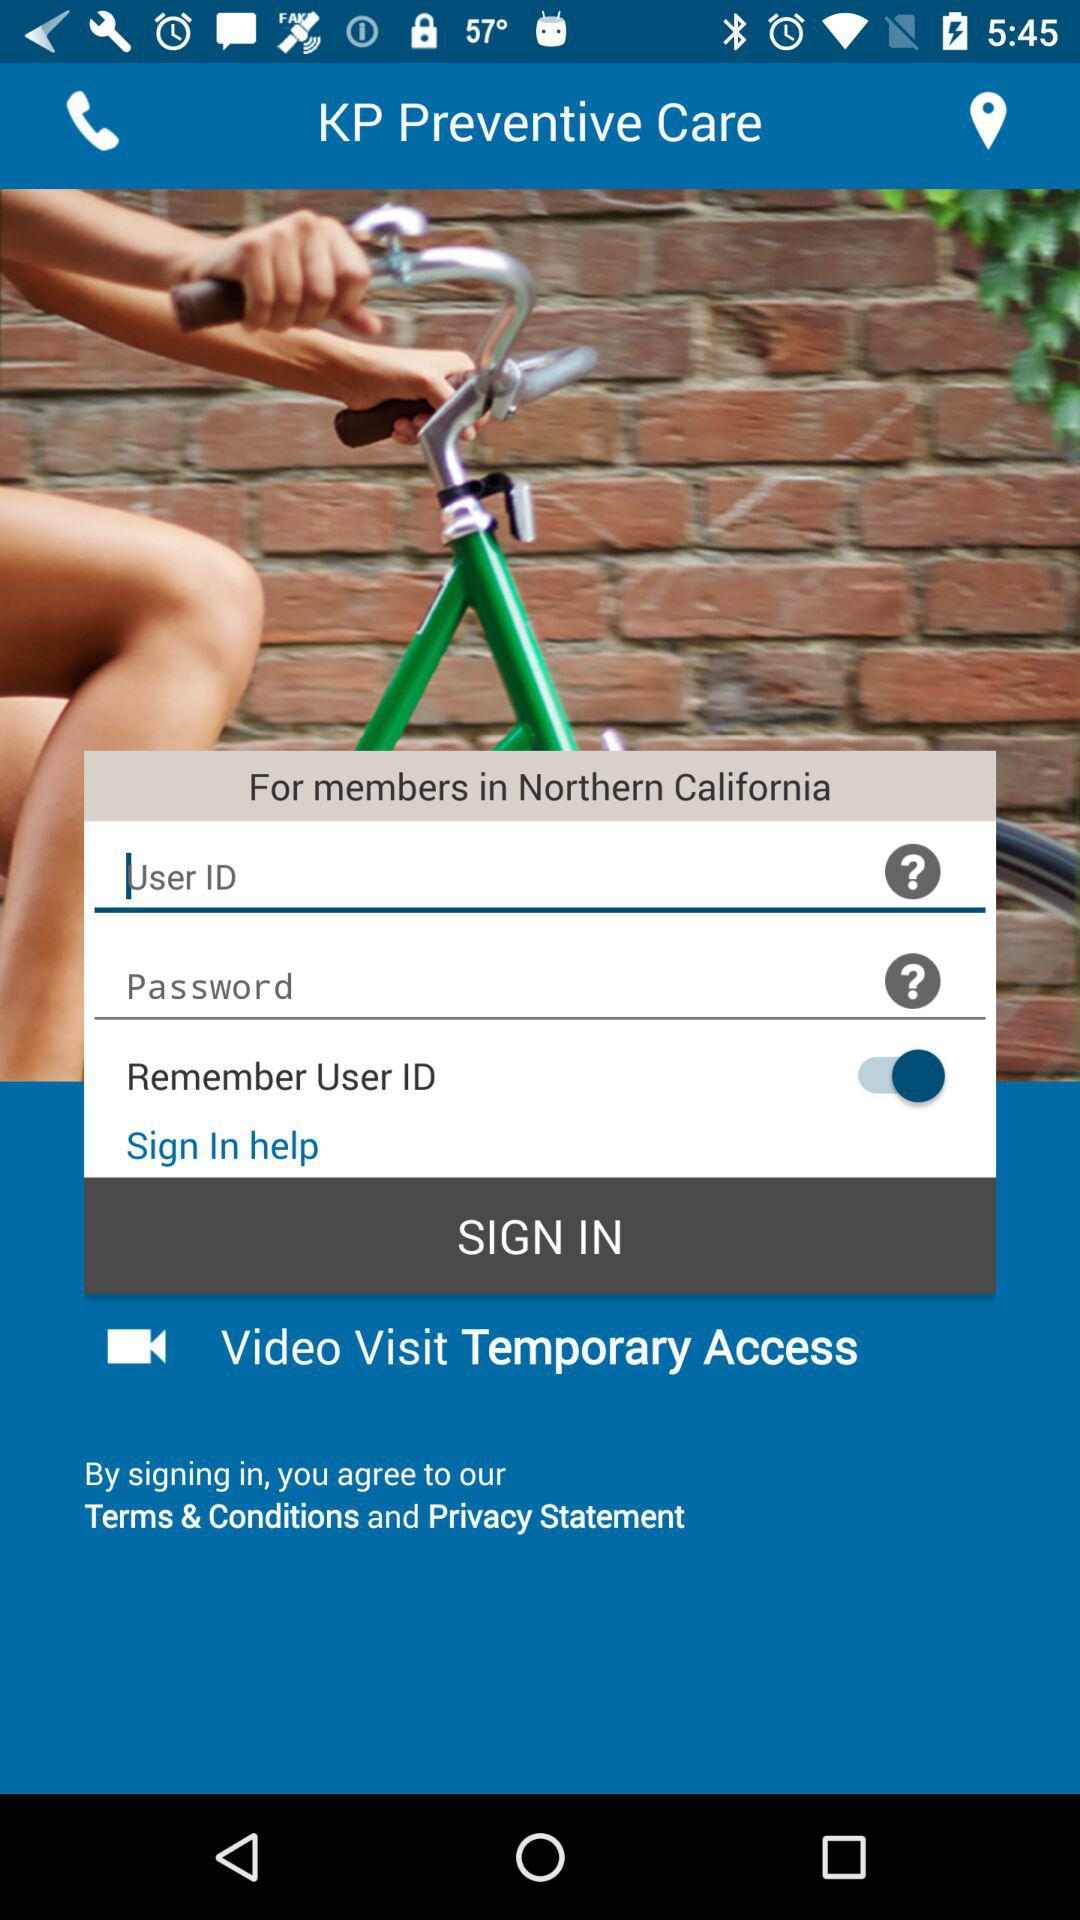What locations' members can use it? Members in Northern California can use it. 